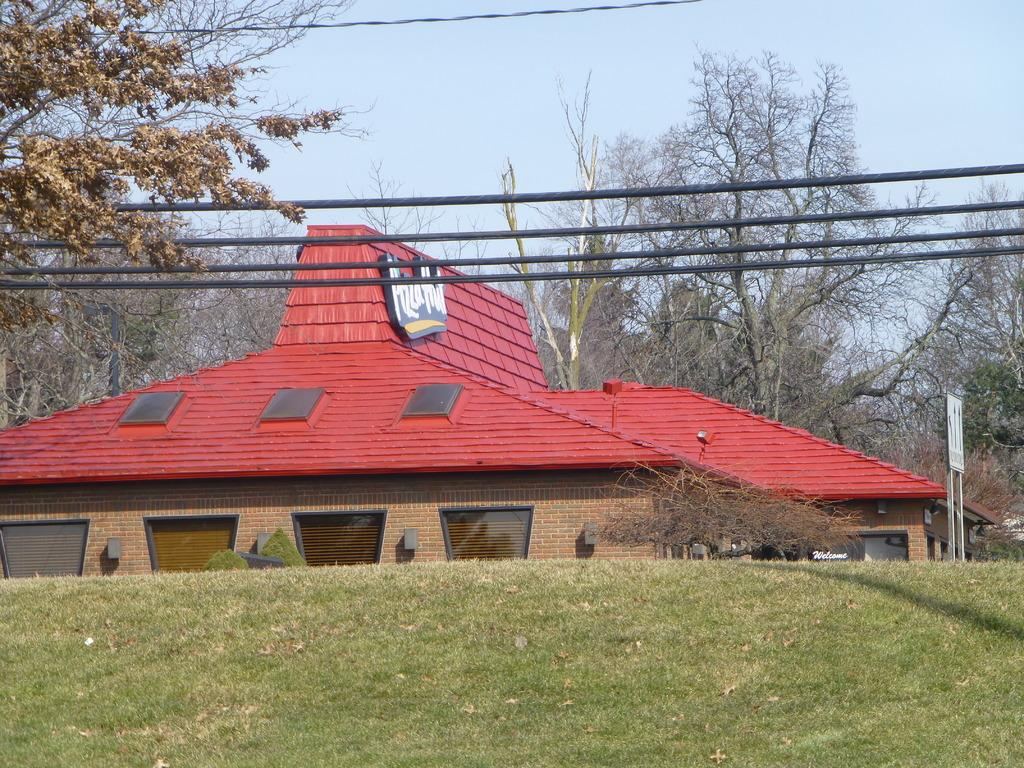What type of vegetation covers the land in the image? The land is covered with grass. Can you describe the building in the image? There is a building with glass windows in the image. What other types of vegetation can be seen in the image? There are plants, trees, and grass in the image. What object can be seen in the image that might be used for displaying information or announcements? There is a board in the image. What type of chain is hanging from the trees in the image? There is no chain present in the image; it features grass, a building, plants, trees, and a board. What color is the pen used to write on the board in the image? There is no pen or writing visible on the board in the image. 